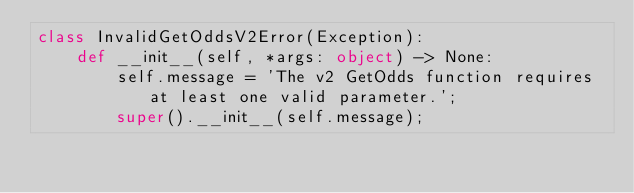<code> <loc_0><loc_0><loc_500><loc_500><_Python_>class InvalidGetOddsV2Error(Exception):
    def __init__(self, *args: object) -> None:
        self.message = 'The v2 GetOdds function requires at least one valid parameter.';
        super().__init__(self.message);</code> 